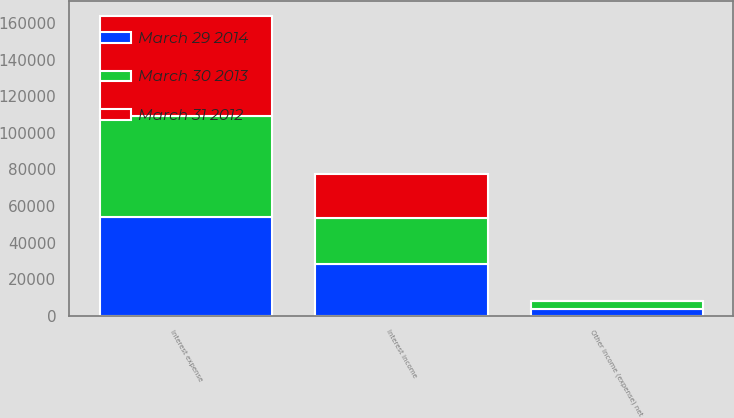Convert chart to OTSL. <chart><loc_0><loc_0><loc_500><loc_500><stacked_bar_chart><ecel><fcel>Interest income<fcel>Interest expense<fcel>Other income (expense) net<nl><fcel>March 29 2014<fcel>28079<fcel>54035<fcel>3597<nl><fcel>March 30 2013<fcel>25574<fcel>55069<fcel>4231<nl><fcel>March 31 2012<fcel>23697<fcel>54576<fcel>157<nl></chart> 